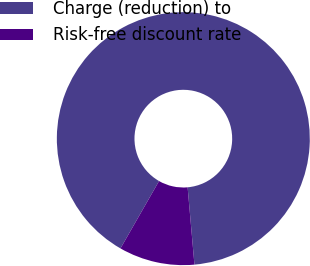<chart> <loc_0><loc_0><loc_500><loc_500><pie_chart><fcel>Charge (reduction) to<fcel>Risk-free discount rate<nl><fcel>90.32%<fcel>9.68%<nl></chart> 